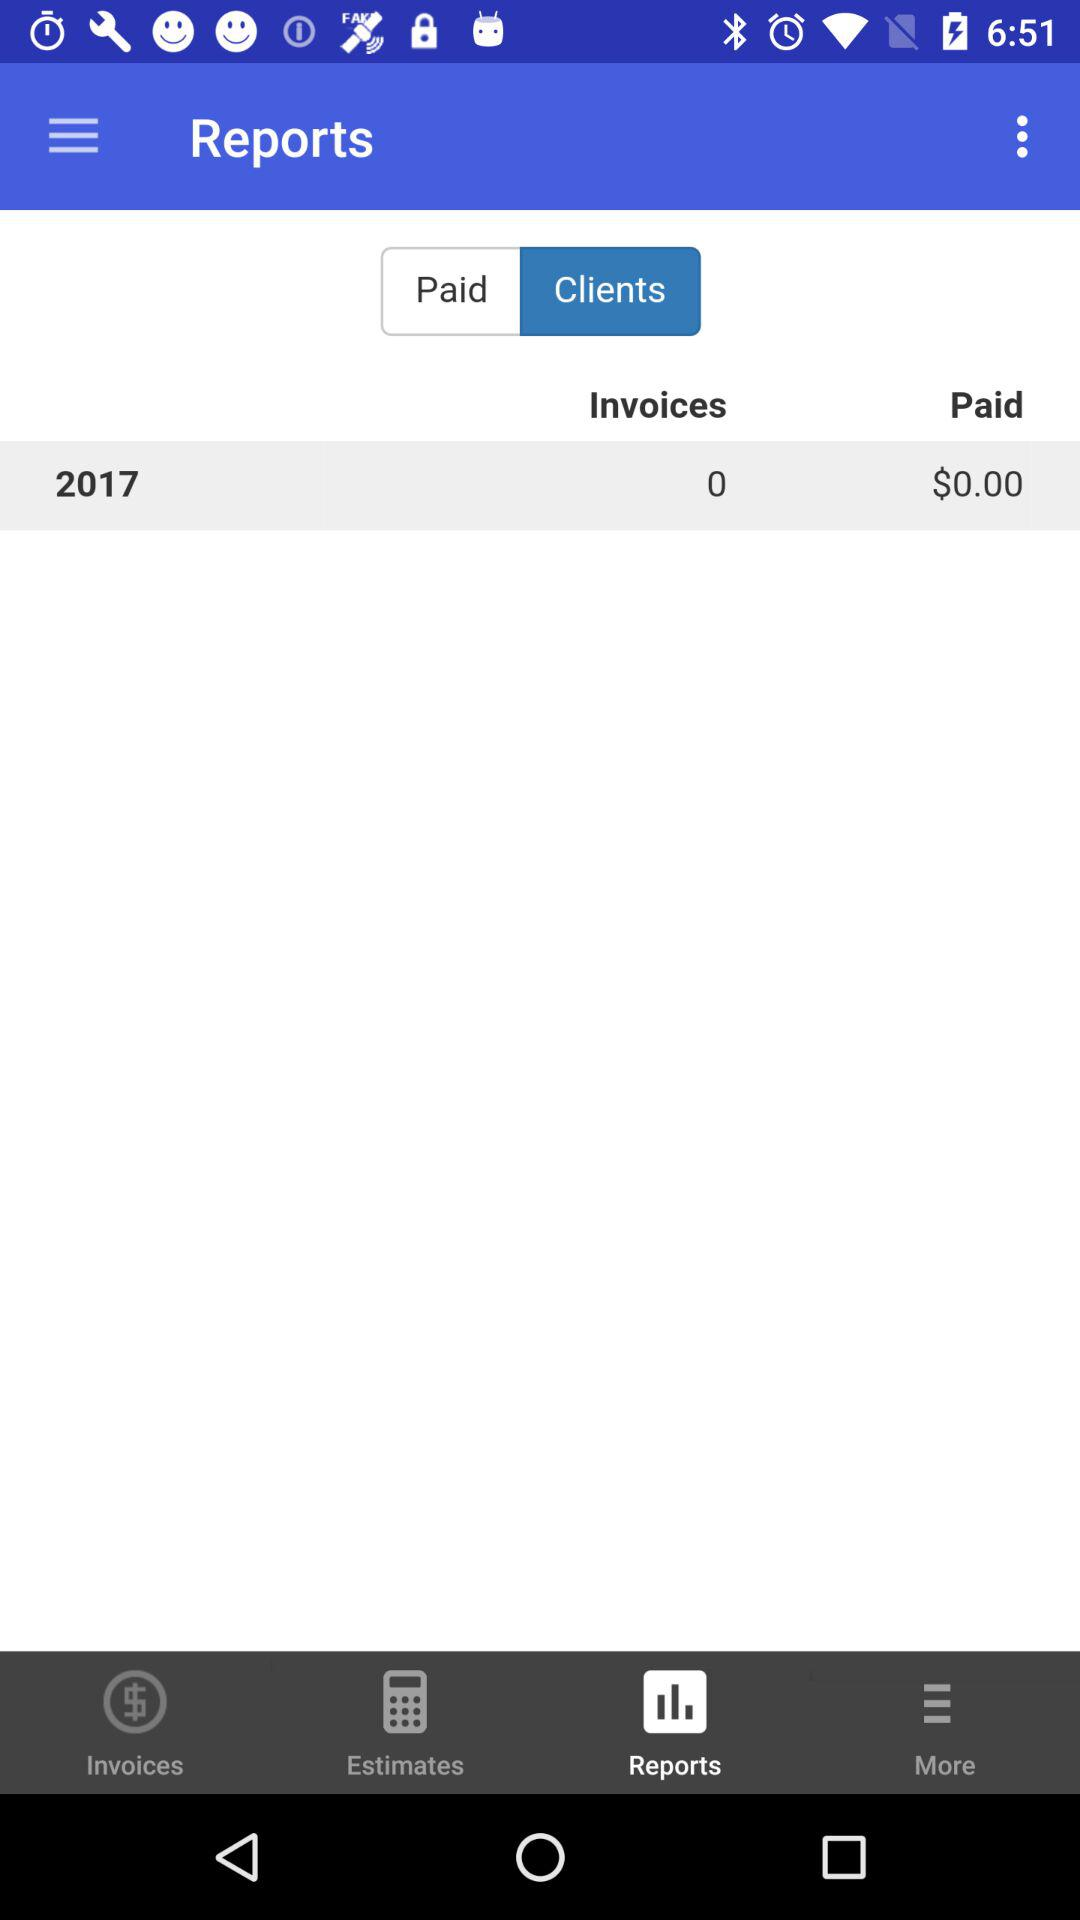How many invoices are there for 2017? There are 0 invoices for 2017. 